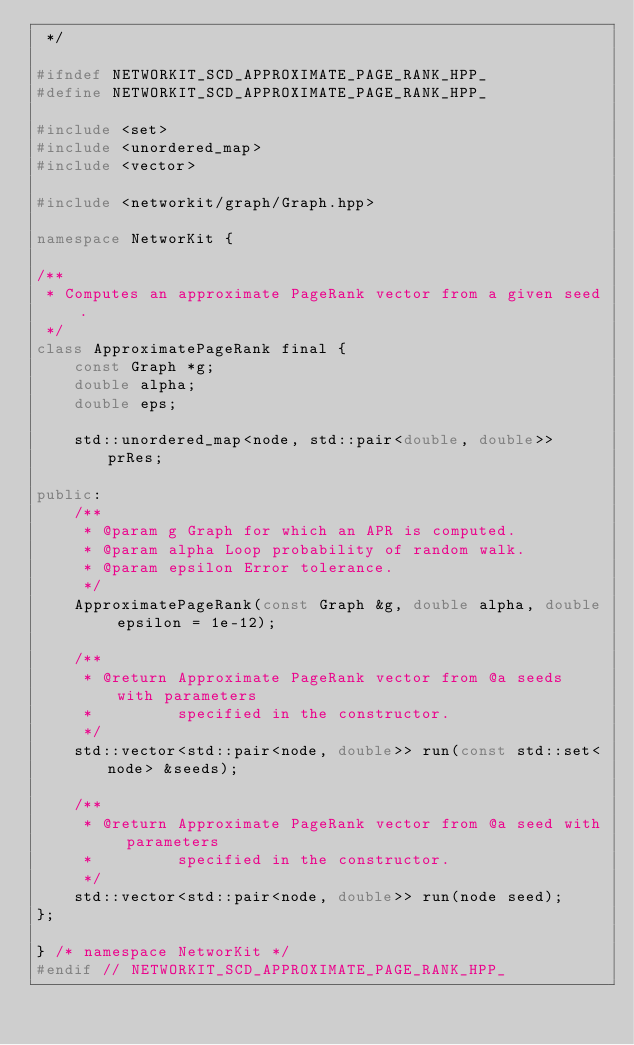<code> <loc_0><loc_0><loc_500><loc_500><_C++_> */

#ifndef NETWORKIT_SCD_APPROXIMATE_PAGE_RANK_HPP_
#define NETWORKIT_SCD_APPROXIMATE_PAGE_RANK_HPP_

#include <set>
#include <unordered_map>
#include <vector>

#include <networkit/graph/Graph.hpp>

namespace NetworKit {

/**
 * Computes an approximate PageRank vector from a given seed.
 */
class ApproximatePageRank final {
    const Graph *g;
    double alpha;
    double eps;

    std::unordered_map<node, std::pair<double, double>> prRes;

public:
    /**
     * @param g Graph for which an APR is computed.
     * @param alpha Loop probability of random walk.
     * @param epsilon Error tolerance.
     */
    ApproximatePageRank(const Graph &g, double alpha, double epsilon = 1e-12);

    /**
     * @return Approximate PageRank vector from @a seeds with parameters
     *         specified in the constructor.
     */
    std::vector<std::pair<node, double>> run(const std::set<node> &seeds);

    /**
     * @return Approximate PageRank vector from @a seed with parameters
     *         specified in the constructor.
     */
    std::vector<std::pair<node, double>> run(node seed);
};

} /* namespace NetworKit */
#endif // NETWORKIT_SCD_APPROXIMATE_PAGE_RANK_HPP_
</code> 